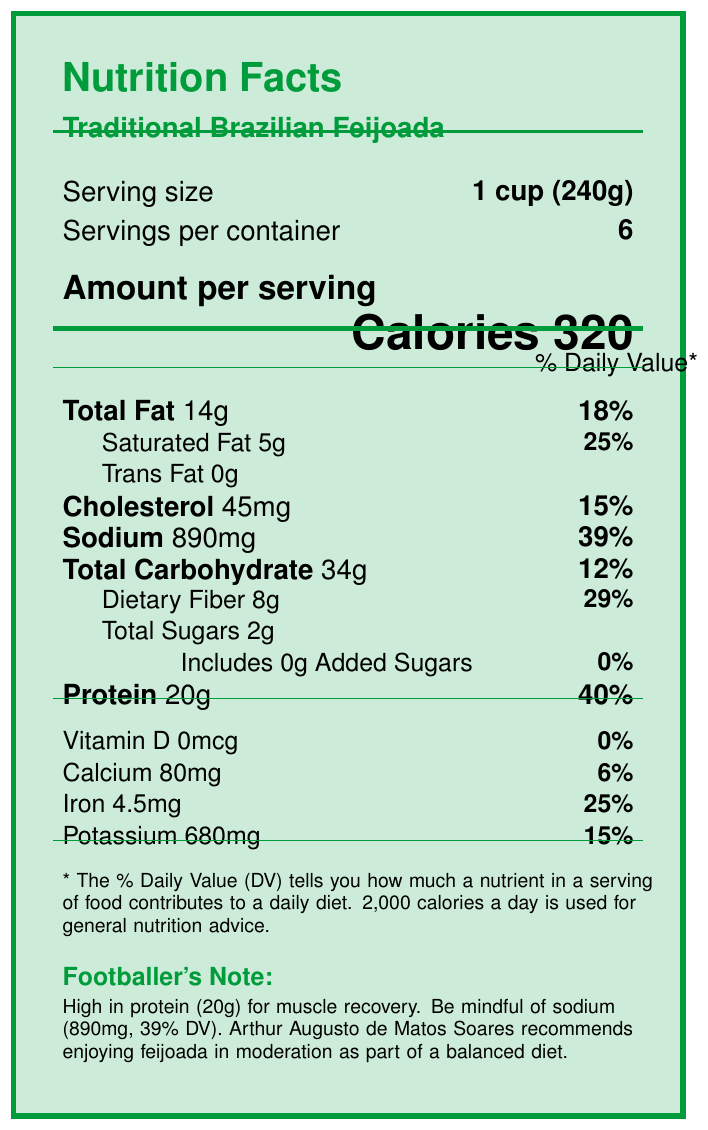what is the serving size? The serving size is specified at the top of the document as "1 cup (240g)".
Answer: 1 cup (240g) What is the protein content per serving? The protein content is listed under the "Protein" section as 20g per serving.
Answer: 20g How much sodium does each serving contain? The sodium content per serving is specified at 890mg in the document.
Answer: 890mg What percentage of the daily value of sodium does one serving of feijoada provide? The document lists the daily value percentage of sodium as 39% next to the sodium content.
Answer: 39% What main note does the footballer's note highlight? The "Footballer's Note" in the document mentions the high protein content and the need to be mindful of the sodium level.
Answer: High in protein (20g) for muscle recovery. Be mindful of sodium (890mg, 39% DV). What are the total carbohydrates in a serving? A. 30g B. 34g C. 40g D. 20g The total carbohydrates listed in the document are 34g per serving.
Answer: B. 34g Which of the following ingredients are present in the feijoada? A. Chicken, Beef, Rice B. Black beans, Sausage, Pork C. Tofu, Rice, Collard greens D. Fish, Pork, Beef The main ingredients listed in the document include Black beans, Sausage, and Pork.
Answer: B. Black beans, Sausage, Pork Is there any added sugar in this feijoada? The document clearly states that there are 0g of added sugars.
Answer: No Is this food suitable for vegans? The feijoada contains pork and beef, which are not suitable for a vegan diet.
Answer: No Summarize the key nutritional information about the protein and sodium content of this feijoada. The document highlights these values in the respective sections and mentions the importance of protein for muscle recovery and the need to be mindful of sodium intake.
Answer: The Traditional Brazilian Feijoada contains 20g of protein and 890mg of sodium per serving, which corresponds to 40% and 39% of the daily value, respectively. What is the preparation tip for a lighter version of this feijoada? The exact preparation tip is not provided in the visual document.
Answer: Not enough information 